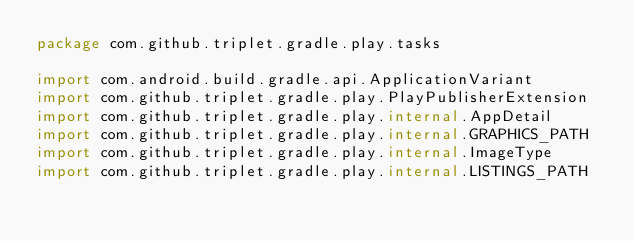<code> <loc_0><loc_0><loc_500><loc_500><_Kotlin_>package com.github.triplet.gradle.play.tasks

import com.android.build.gradle.api.ApplicationVariant
import com.github.triplet.gradle.play.PlayPublisherExtension
import com.github.triplet.gradle.play.internal.AppDetail
import com.github.triplet.gradle.play.internal.GRAPHICS_PATH
import com.github.triplet.gradle.play.internal.ImageType
import com.github.triplet.gradle.play.internal.LISTINGS_PATH</code> 